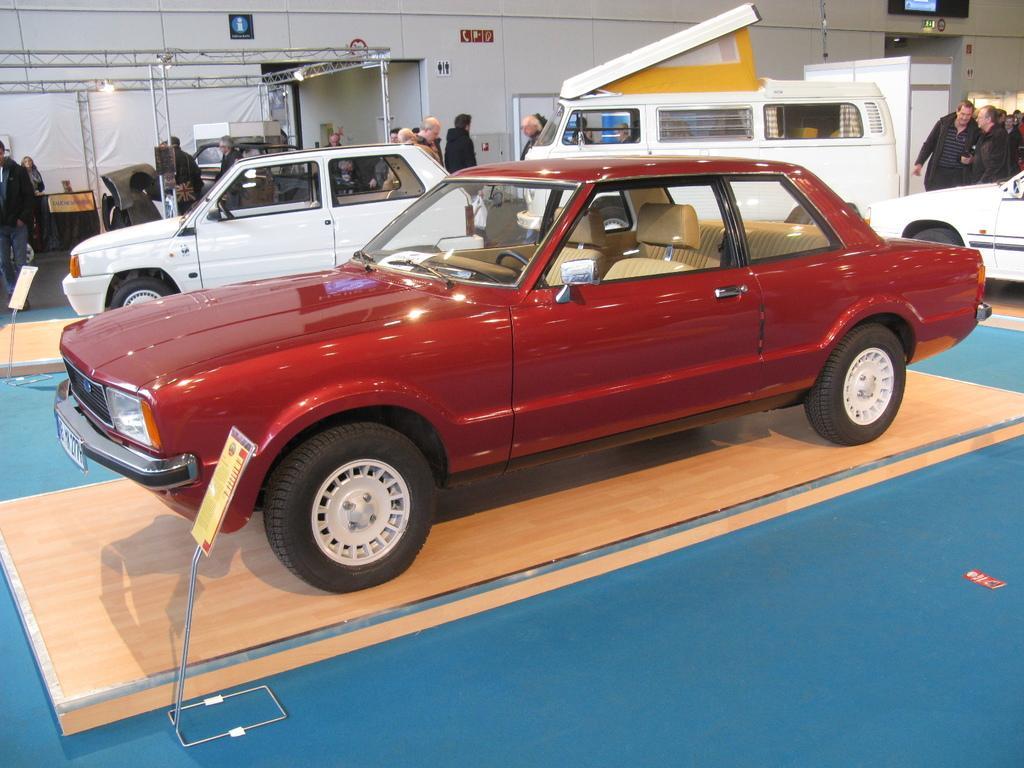Describe this image in one or two sentences. Indoor picture. This red car is highlighted. Beside this red car there is a information board. This is a white car and this is a white van. People are standing. This is rod. 